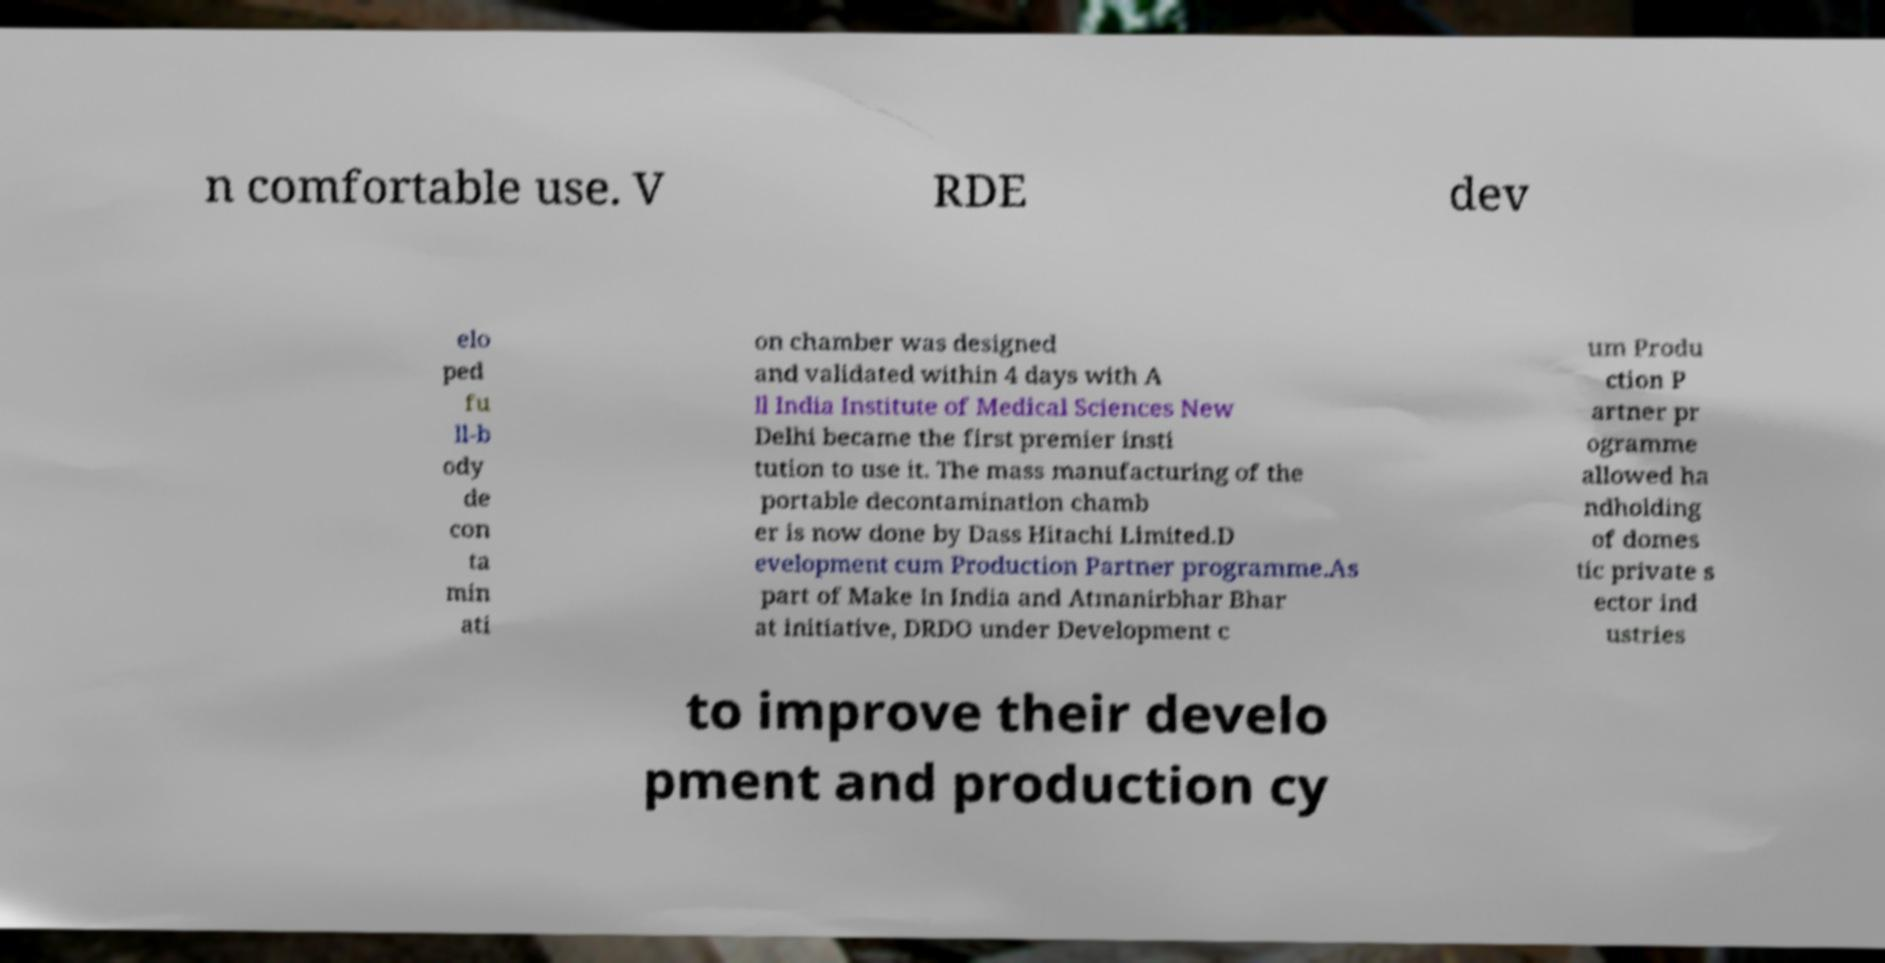Can you read and provide the text displayed in the image?This photo seems to have some interesting text. Can you extract and type it out for me? n comfortable use. V RDE dev elo ped fu ll-b ody de con ta min ati on chamber was designed and validated within 4 days with A ll India Institute of Medical Sciences New Delhi became the first premier insti tution to use it. The mass manufacturing of the portable decontamination chamb er is now done by Dass Hitachi Limited.D evelopment cum Production Partner programme.As part of Make In India and Atmanirbhar Bhar at initiative, DRDO under Development c um Produ ction P artner pr ogramme allowed ha ndholding of domes tic private s ector ind ustries to improve their develo pment and production cy 